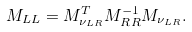Convert formula to latex. <formula><loc_0><loc_0><loc_500><loc_500>M _ { L L } = M _ { \nu _ { L R } } ^ { T } M _ { R R } ^ { - 1 } M _ { \nu _ { L R } } .</formula> 